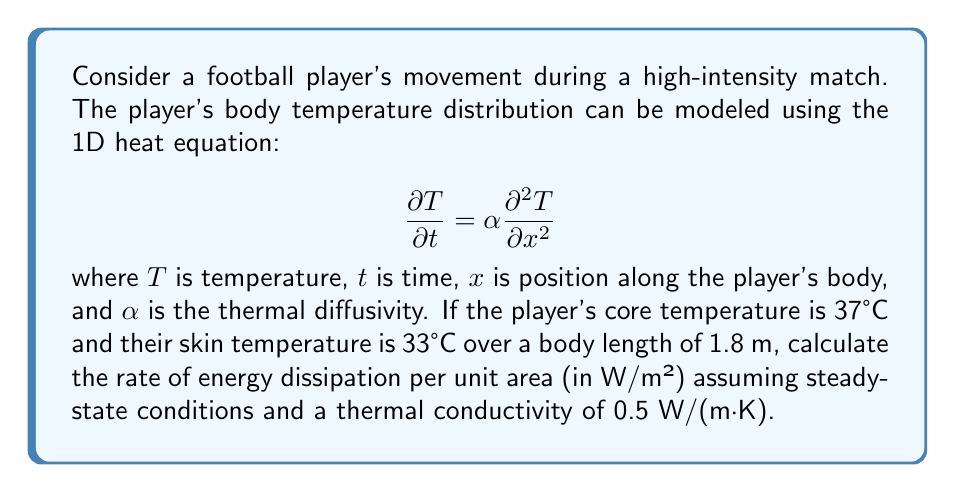Can you answer this question? To solve this problem, we'll follow these steps:

1) In steady-state conditions, the temperature distribution doesn't change with time, so $\frac{\partial T}{\partial t} = 0$. The heat equation simplifies to:

   $$0 = \alpha \frac{\partial^2 T}{\partial x^2}$$

2) This implies that the temperature distribution is linear:

   $$T(x) = ax + b$$

   where $a$ and $b$ are constants.

3) We can determine these constants using the boundary conditions:
   At $x = 0$ (core): $T = 37°C$
   At $x = 1.8$ m (skin): $T = 33°C$

4) Substituting these into our linear equation:
   $37 = b$ (at $x = 0$)
   $33 = 1.8a + 37$ (at $x = 1.8$)

5) Solving for $a$:
   $-4 = 1.8a$
   $a = -\frac{4}{1.8} = -2.22$ °C/m

6) The temperature gradient is constant and equal to $a$:

   $$\frac{dT}{dx} = -2.22 \text{ °C/m}$$

7) The rate of heat flow (energy dissipation) per unit area is given by Fourier's law:

   $$q = -k\frac{dT}{dx}$$

   where $k$ is the thermal conductivity.

8) Substituting the values:

   $$q = -(0.5 \text{ W/(m·K)})(-2.22 \text{ °C/m}) = 1.11 \text{ W/m²}$$

Thus, the rate of energy dissipation per unit area is 1.11 W/m².
Answer: 1.11 W/m² 